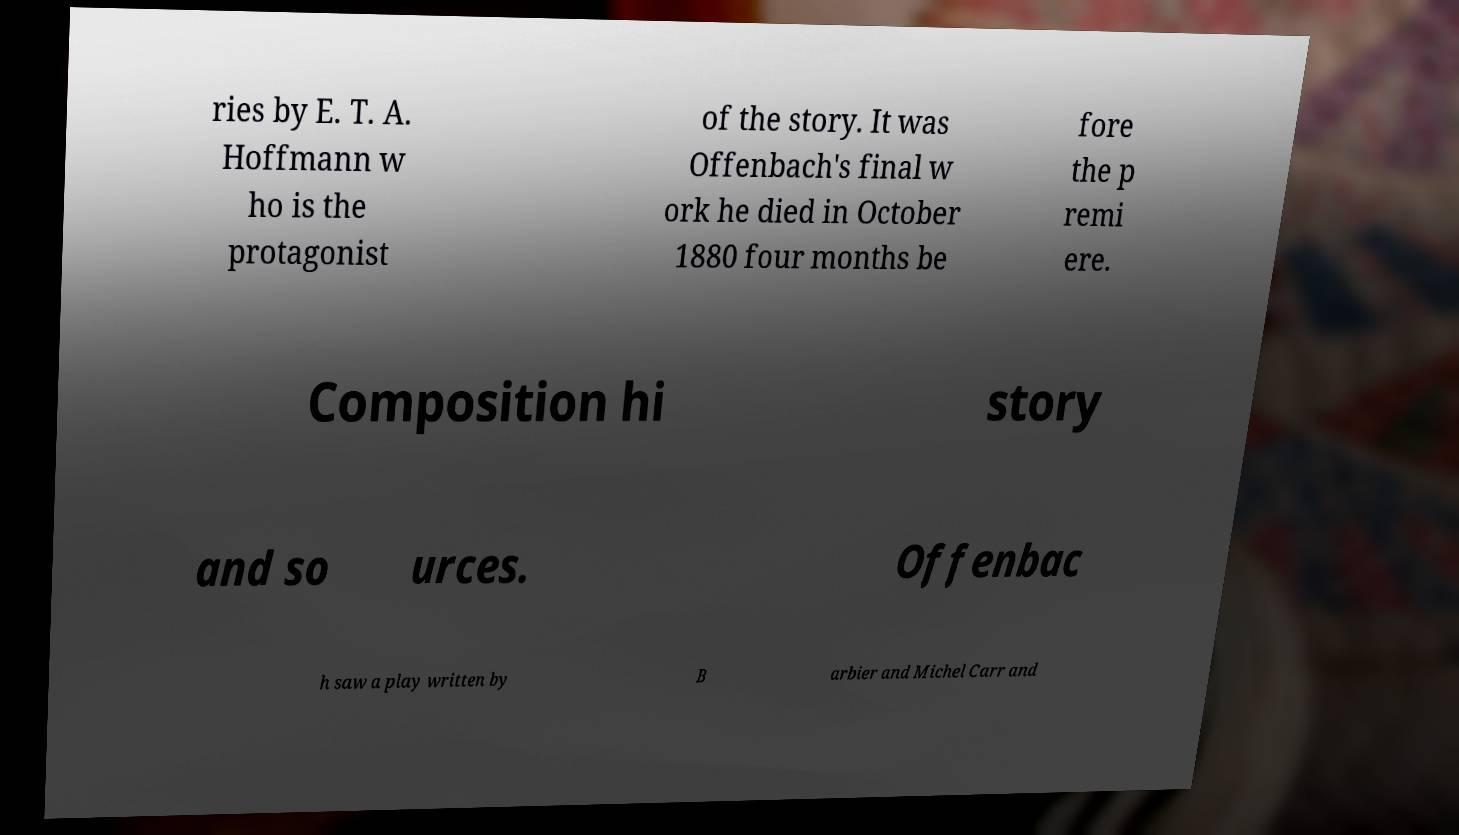Could you extract and type out the text from this image? ries by E. T. A. Hoffmann w ho is the protagonist of the story. It was Offenbach's final w ork he died in October 1880 four months be fore the p remi ere. Composition hi story and so urces. Offenbac h saw a play written by B arbier and Michel Carr and 